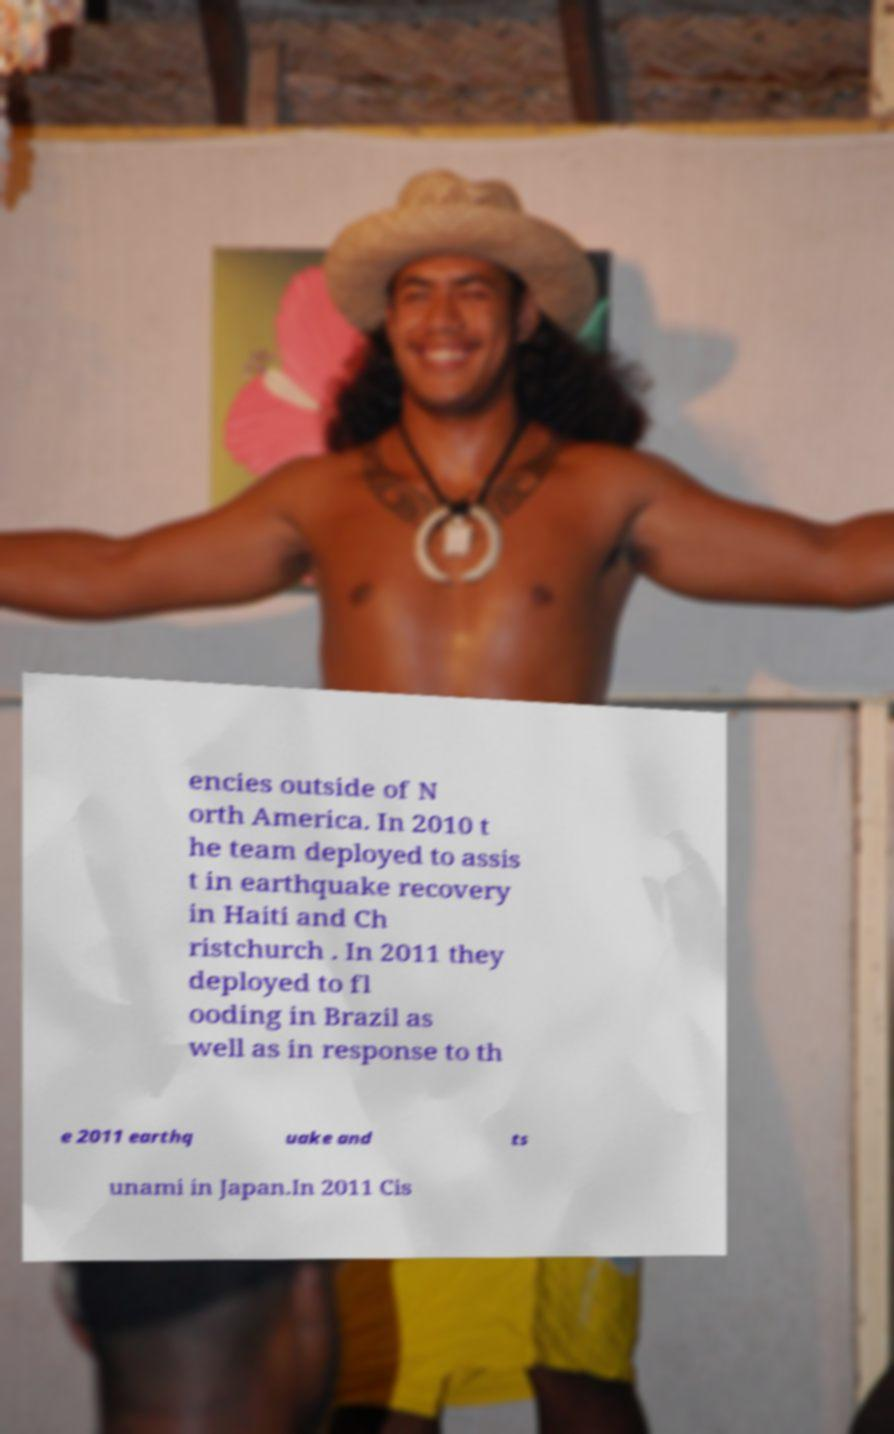Could you extract and type out the text from this image? encies outside of N orth America. In 2010 t he team deployed to assis t in earthquake recovery in Haiti and Ch ristchurch . In 2011 they deployed to fl ooding in Brazil as well as in response to th e 2011 earthq uake and ts unami in Japan.In 2011 Cis 